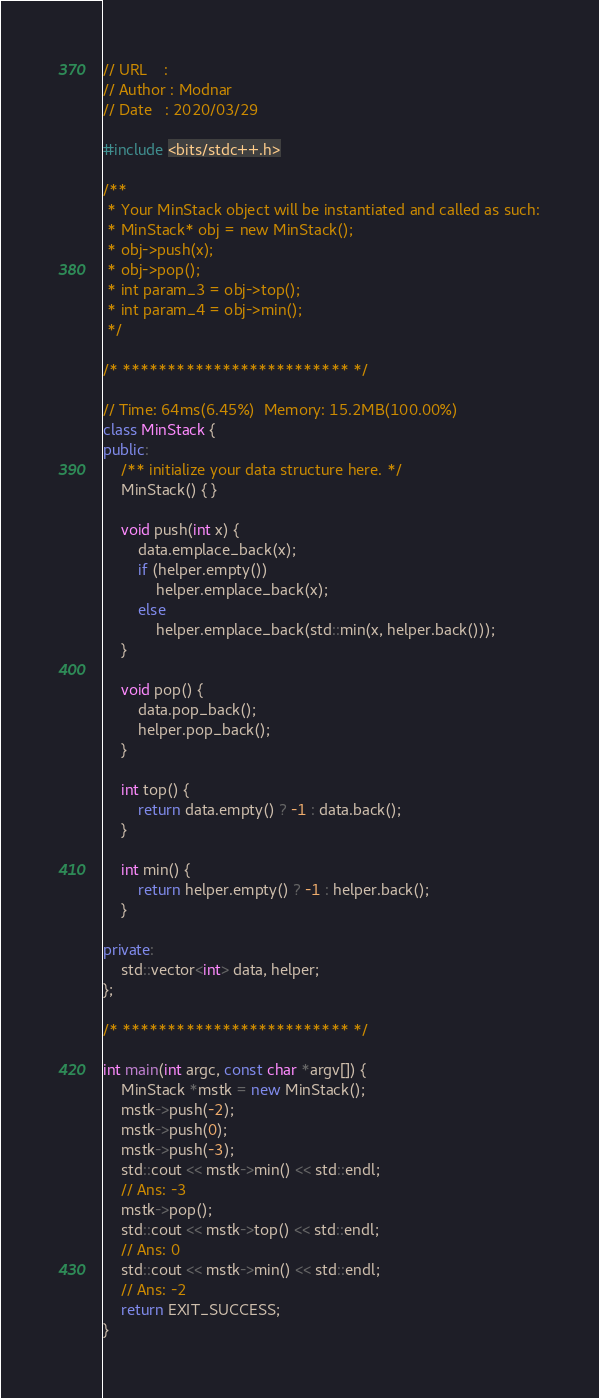Convert code to text. <code><loc_0><loc_0><loc_500><loc_500><_C++_>// URL    : 
// Author : Modnar
// Date   : 2020/03/29

#include <bits/stdc++.h>

/**
 * Your MinStack object will be instantiated and called as such:
 * MinStack* obj = new MinStack();
 * obj->push(x);
 * obj->pop();
 * int param_3 = obj->top();
 * int param_4 = obj->min();
 */

/* ************************* */

// Time: 64ms(6.45%)  Memory: 15.2MB(100.00%)
class MinStack {
public:
    /** initialize your data structure here. */
    MinStack() { }
    
    void push(int x) {
        data.emplace_back(x);
        if (helper.empty())
            helper.emplace_back(x);
        else
            helper.emplace_back(std::min(x, helper.back()));
    }
    
    void pop() {
        data.pop_back();
        helper.pop_back();
    }
    
    int top() {
        return data.empty() ? -1 : data.back();
    }
    
    int min() {
        return helper.empty() ? -1 : helper.back();
    }

private:
    std::vector<int> data, helper;
};

/* ************************* */

int main(int argc, const char *argv[]) {
    MinStack *mstk = new MinStack();
    mstk->push(-2);
    mstk->push(0);
    mstk->push(-3);
    std::cout << mstk->min() << std::endl;
    // Ans: -3
    mstk->pop();
    std::cout << mstk->top() << std::endl;
    // Ans: 0
    std::cout << mstk->min() << std::endl;
    // Ans: -2
    return EXIT_SUCCESS;
}
</code> 